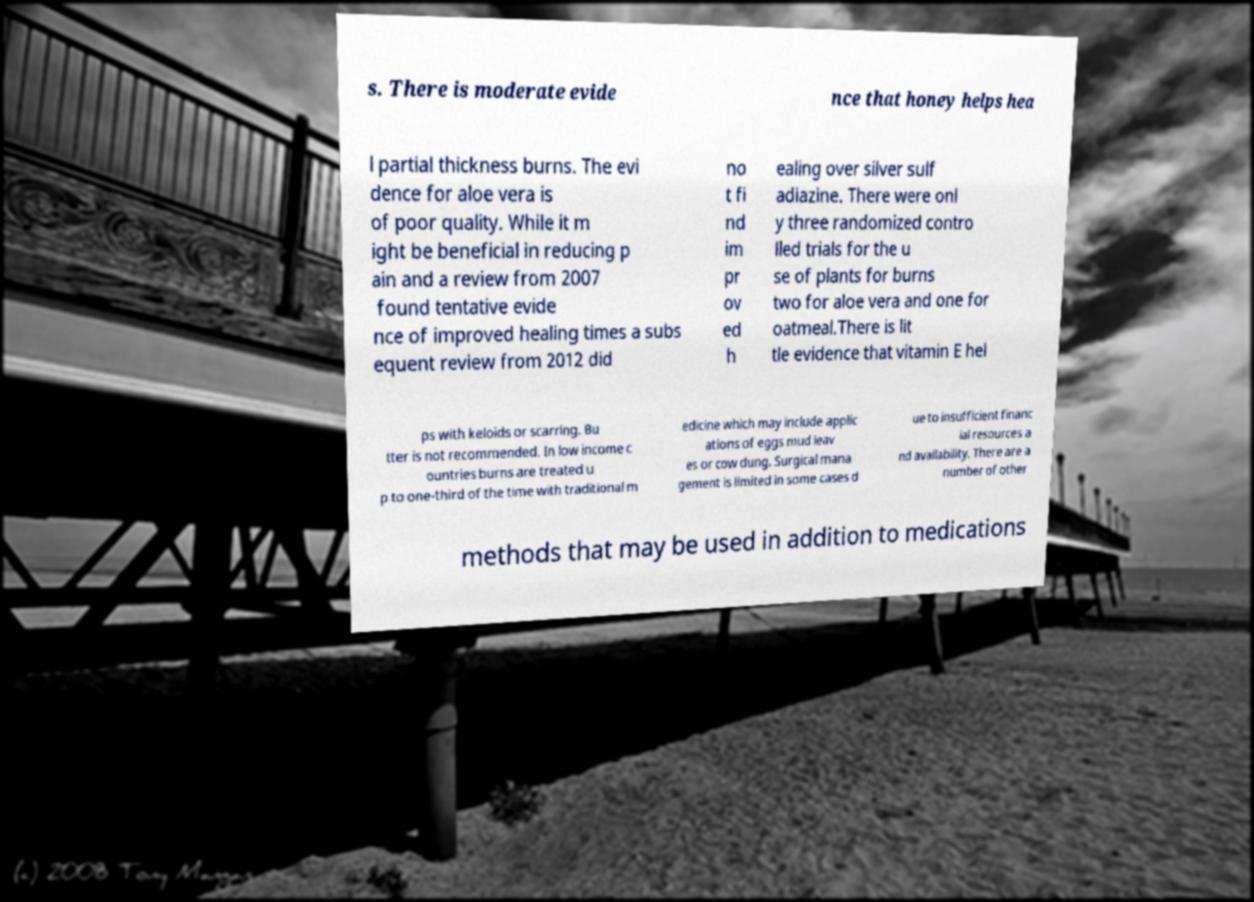Can you accurately transcribe the text from the provided image for me? s. There is moderate evide nce that honey helps hea l partial thickness burns. The evi dence for aloe vera is of poor quality. While it m ight be beneficial in reducing p ain and a review from 2007 found tentative evide nce of improved healing times a subs equent review from 2012 did no t fi nd im pr ov ed h ealing over silver sulf adiazine. There were onl y three randomized contro lled trials for the u se of plants for burns two for aloe vera and one for oatmeal.There is lit tle evidence that vitamin E hel ps with keloids or scarring. Bu tter is not recommended. In low income c ountries burns are treated u p to one-third of the time with traditional m edicine which may include applic ations of eggs mud leav es or cow dung. Surgical mana gement is limited in some cases d ue to insufficient financ ial resources a nd availability. There are a number of other methods that may be used in addition to medications 